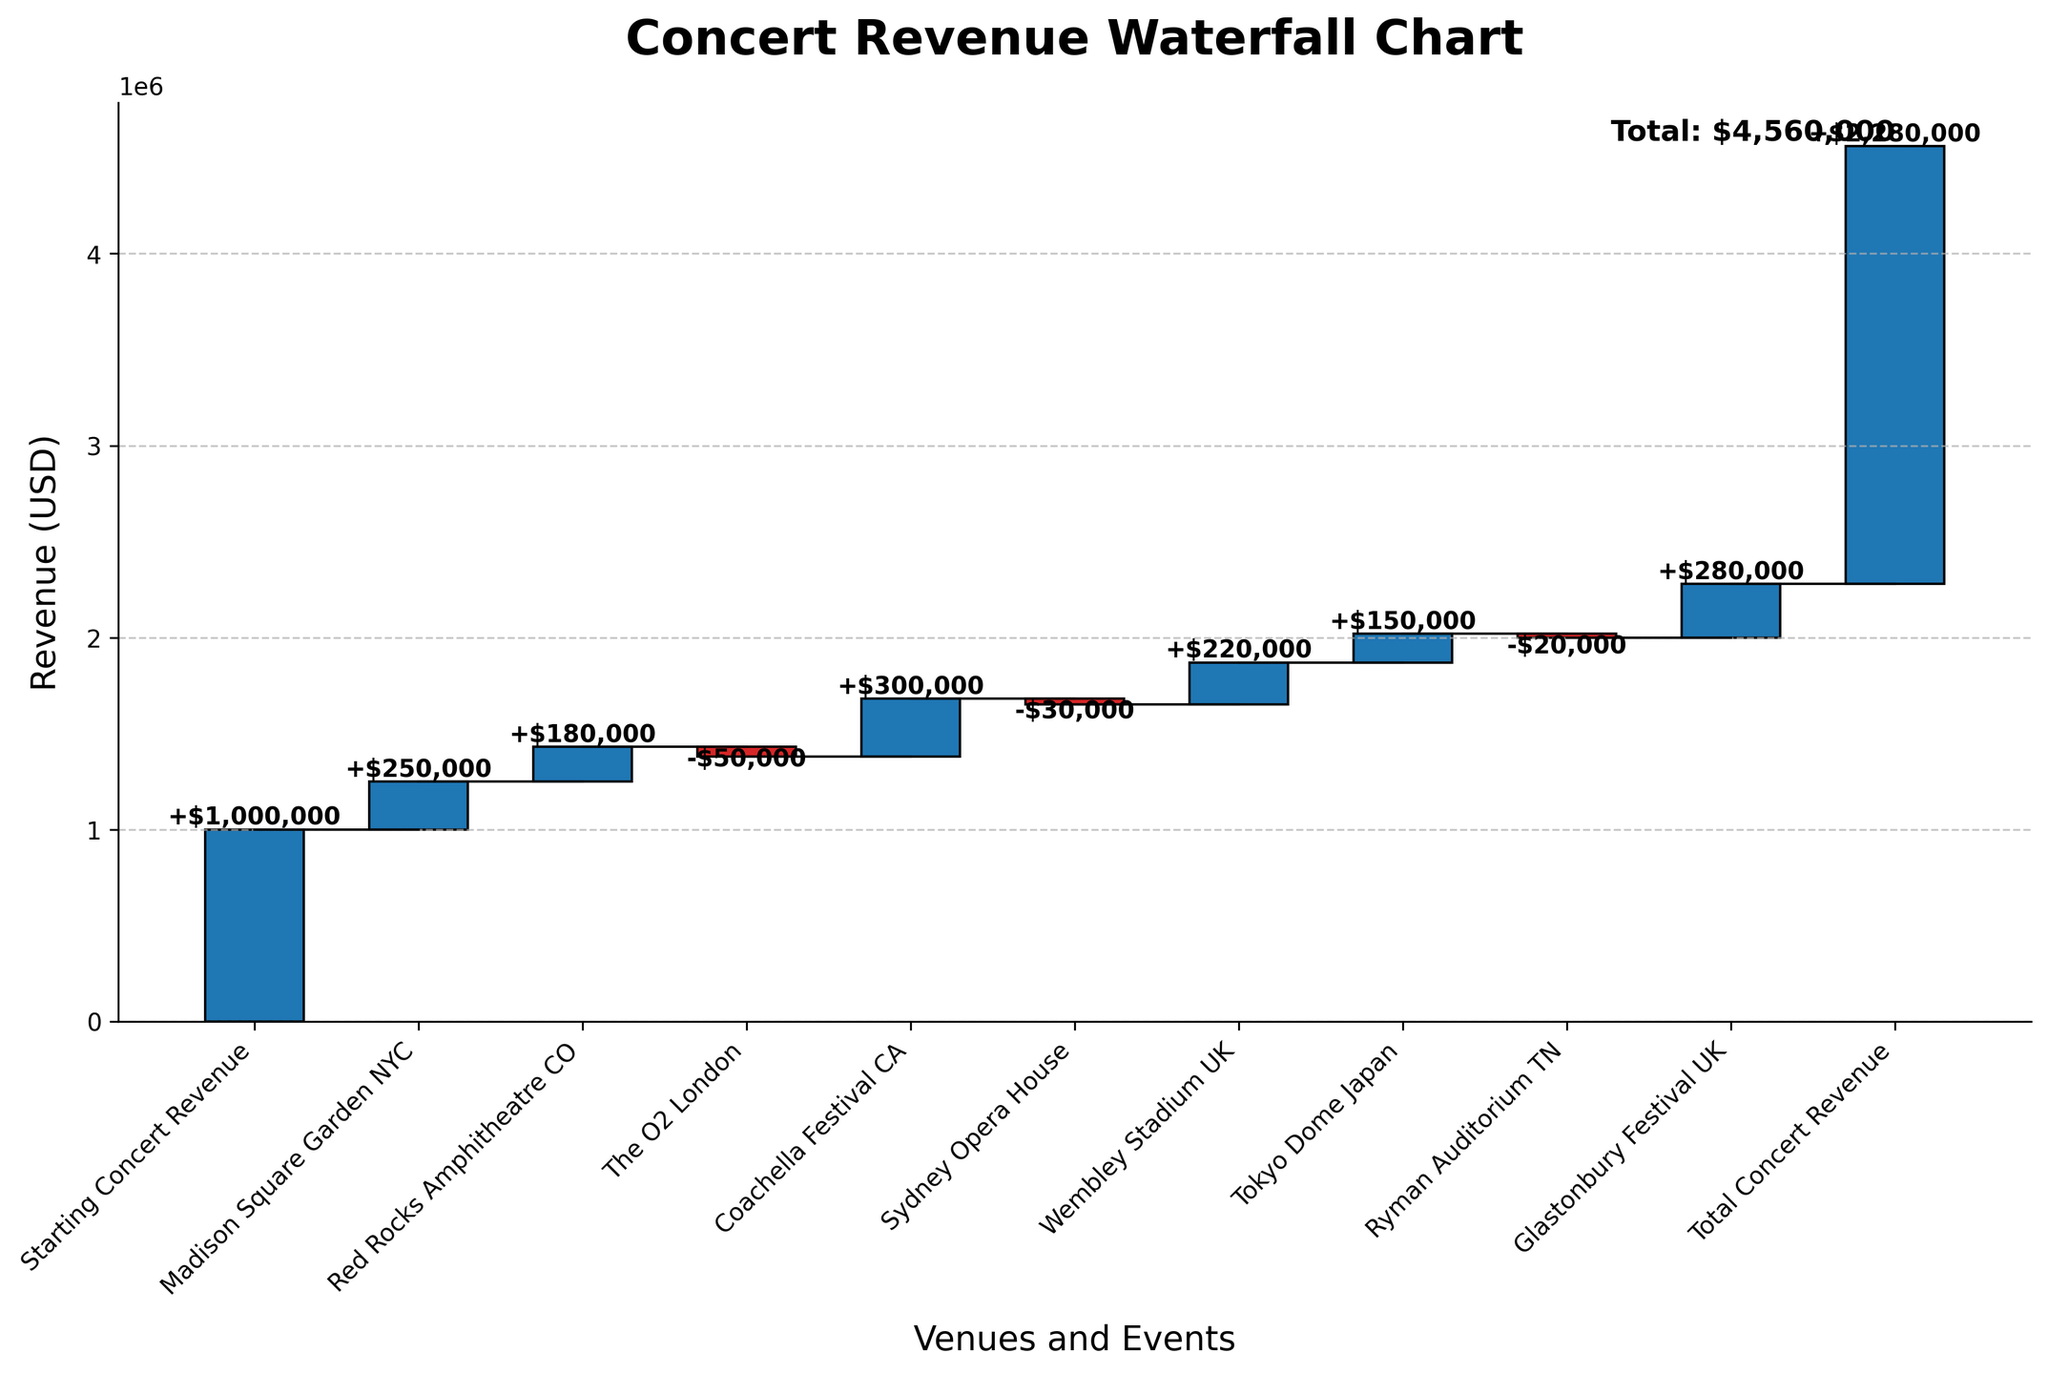Which venue contributed the most revenue? The positive bar for Coachella Festival CA is the tallest, indicating that it has the highest revenue contribution.
Answer: Coachella Festival CA What is the total concert revenue? The final cumulative total at the end of the waterfall chart is represented, which sums all values from the starting concert revenue to the final event.
Answer: $2,280,000 How much revenue did The O2 London contribute or reduce? The bar for The O2 London is negative, showing a reduction in revenue. The label next to the bar indicates this value.
Answer: -$50,000 Which venues contributed negative revenue? The negative revenue contributions are shown by the bars below the horizontal axis. These are The O2 London, Sydney Opera House, and Ryman Auditorium TN.
Answer: The O2 London, Sydney Opera House, Ryman Auditorium TN What was the cumulative revenue after Madison Square Garden NYC? The cumulative sum after the first bar (Madison Square Garden NYC) can be observed by looking at the height of the second connecting line from the start.
Answer: $1,250,000 What was the difference in revenue generated between Tokyo Dome Japan and Ryman Auditorium TN? Subtract the negative value of Ryman Auditorium TN from the positive value of Tokyo Dome Japan to find the difference.
Answer: $170,000 Which venue's revenue contribution resulted in the smallest positive increase? Among the positive bars, the smallest increase in height represents the smallest positive increase, corresponding to Tokyo Dome Japan.
Answer: Tokyo Dome Japan What is the cumulative revenue before the contribution of Glastonbury Festival UK? The cumulative sum just before Glastonbury Festival UK can be observed by the height of the connecting line just before the final bar.
Answer: $2,000,000 What was the starting concert revenue? The starting concert revenue is stated at the beginning of the waterfall chart.
Answer: $1,000,000 By how much did the revenue increase after Coachella Festival CA compared to the start? Look at the cumulative total just before and after Coachella Festival CA, calculate the increase by subtracting the cumulative value after Coachella from the starting revenue.
Answer: $300,000 